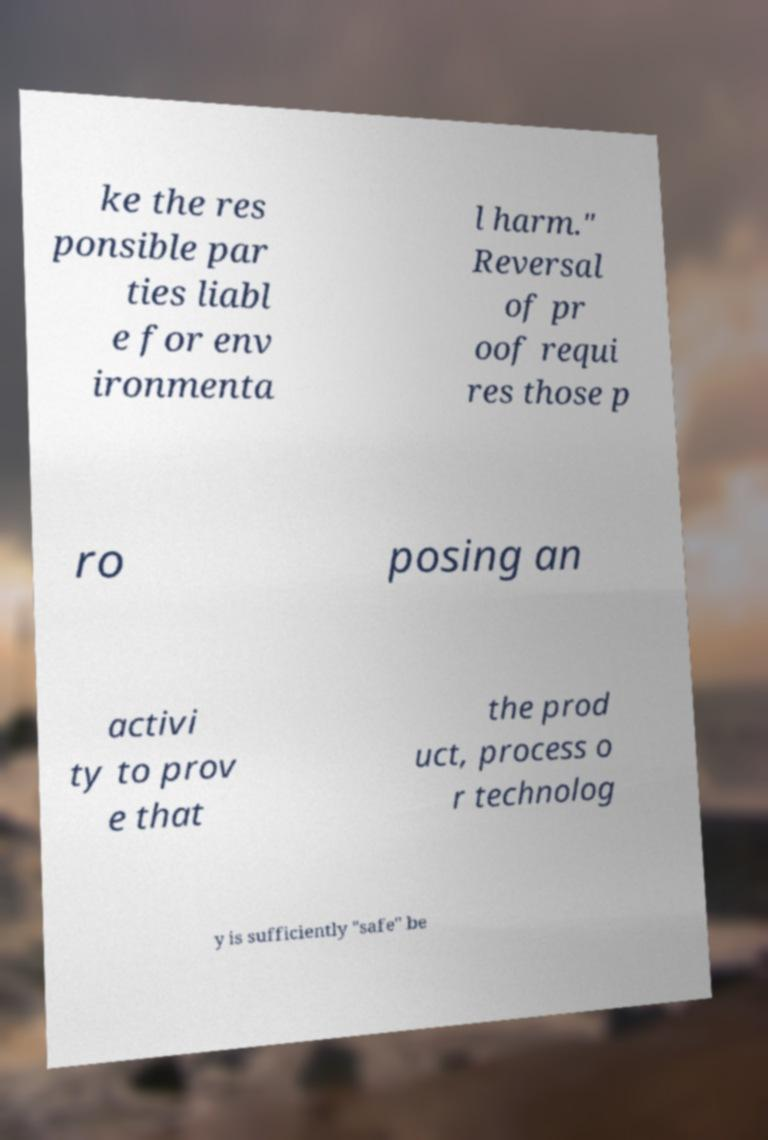What messages or text are displayed in this image? I need them in a readable, typed format. ke the res ponsible par ties liabl e for env ironmenta l harm." Reversal of pr oof requi res those p ro posing an activi ty to prov e that the prod uct, process o r technolog y is sufficiently "safe" be 